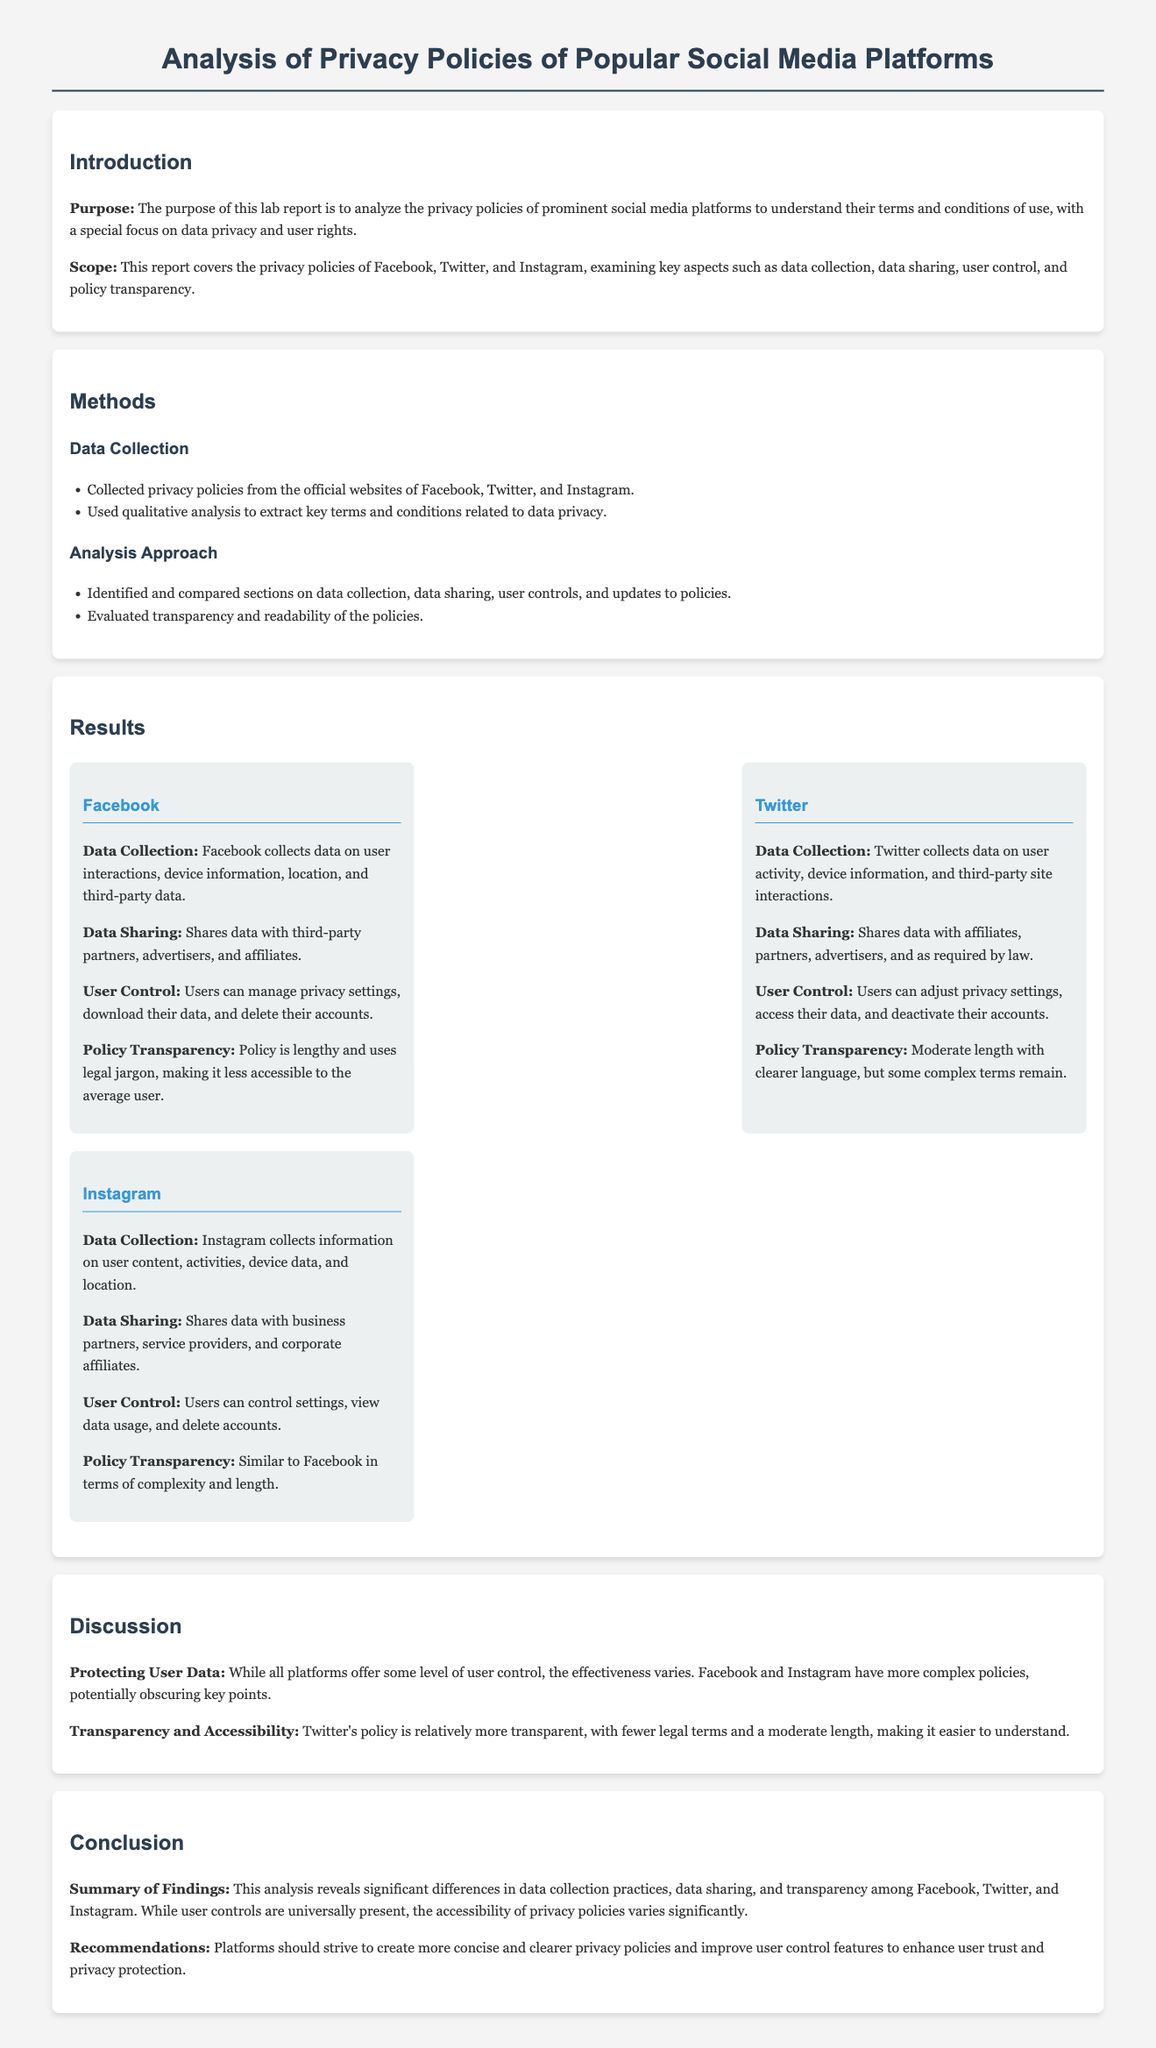What is the purpose of the lab report? The purpose is to analyze the privacy policies of prominent social media platforms to understand their terms and conditions of use, with a special focus on data privacy and user rights.
Answer: To analyze privacy policies Which social media platforms are covered in the report? The report covers the privacy policies of Facebook, Twitter, and Instagram.
Answer: Facebook, Twitter, Instagram How does Facebook manage user control? Facebook allows users to manage privacy settings, download their data, and delete their accounts.
Answer: Manage settings, download data, delete accounts Which platform has a relatively more transparent policy? Twitter's policy is relatively more transparent, with fewer legal terms and a moderate length.
Answer: Twitter What is a common issue found in Facebook's privacy policy? Facebook's policy is lengthy and uses legal jargon, making it less accessible to the average user.
Answer: Lengthy and legal jargon What type of analysis was used in the report? The report used qualitative analysis to extract key terms and conditions related to data privacy.
Answer: Qualitative analysis What are the recommendations made in the conclusion? Platforms should strive to create more concise and clearer privacy policies and enhance user control features.
Answer: More concise policies 